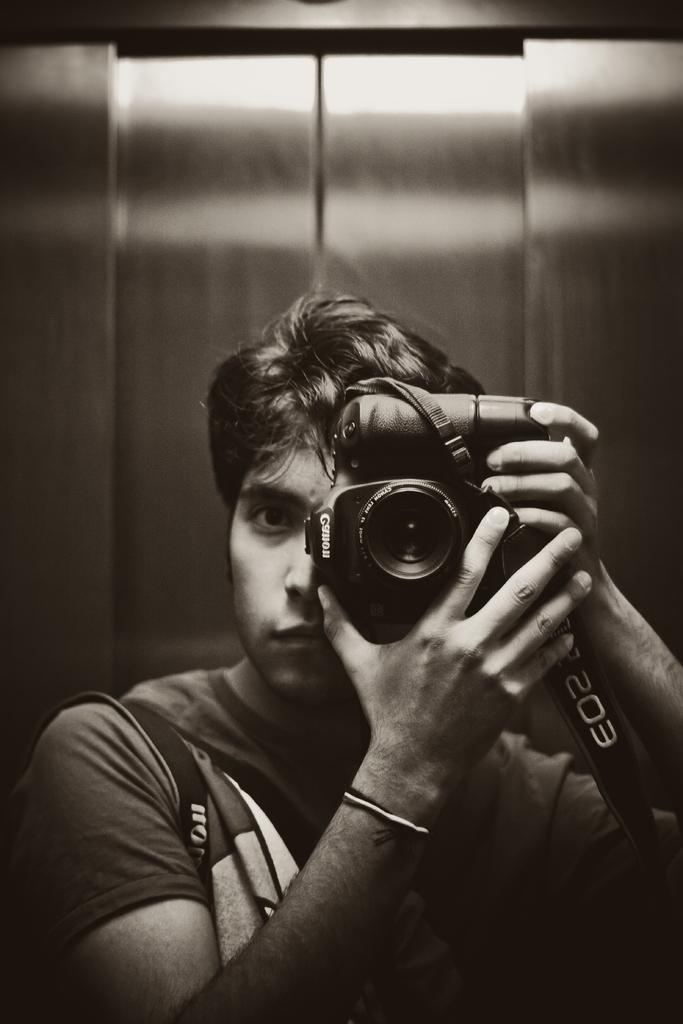Who is the main subject in the image? There is a man in the image. What is the man holding in his hands? The man is holding a camera in his hands. What is the condition of the hospital in the image? There is no hospital present in the image; it only features a man holding a camera. What type of powder can be seen on the man's hands in the image? There is no powder visible on the man's hands in the image; he is simply holding a camera. 